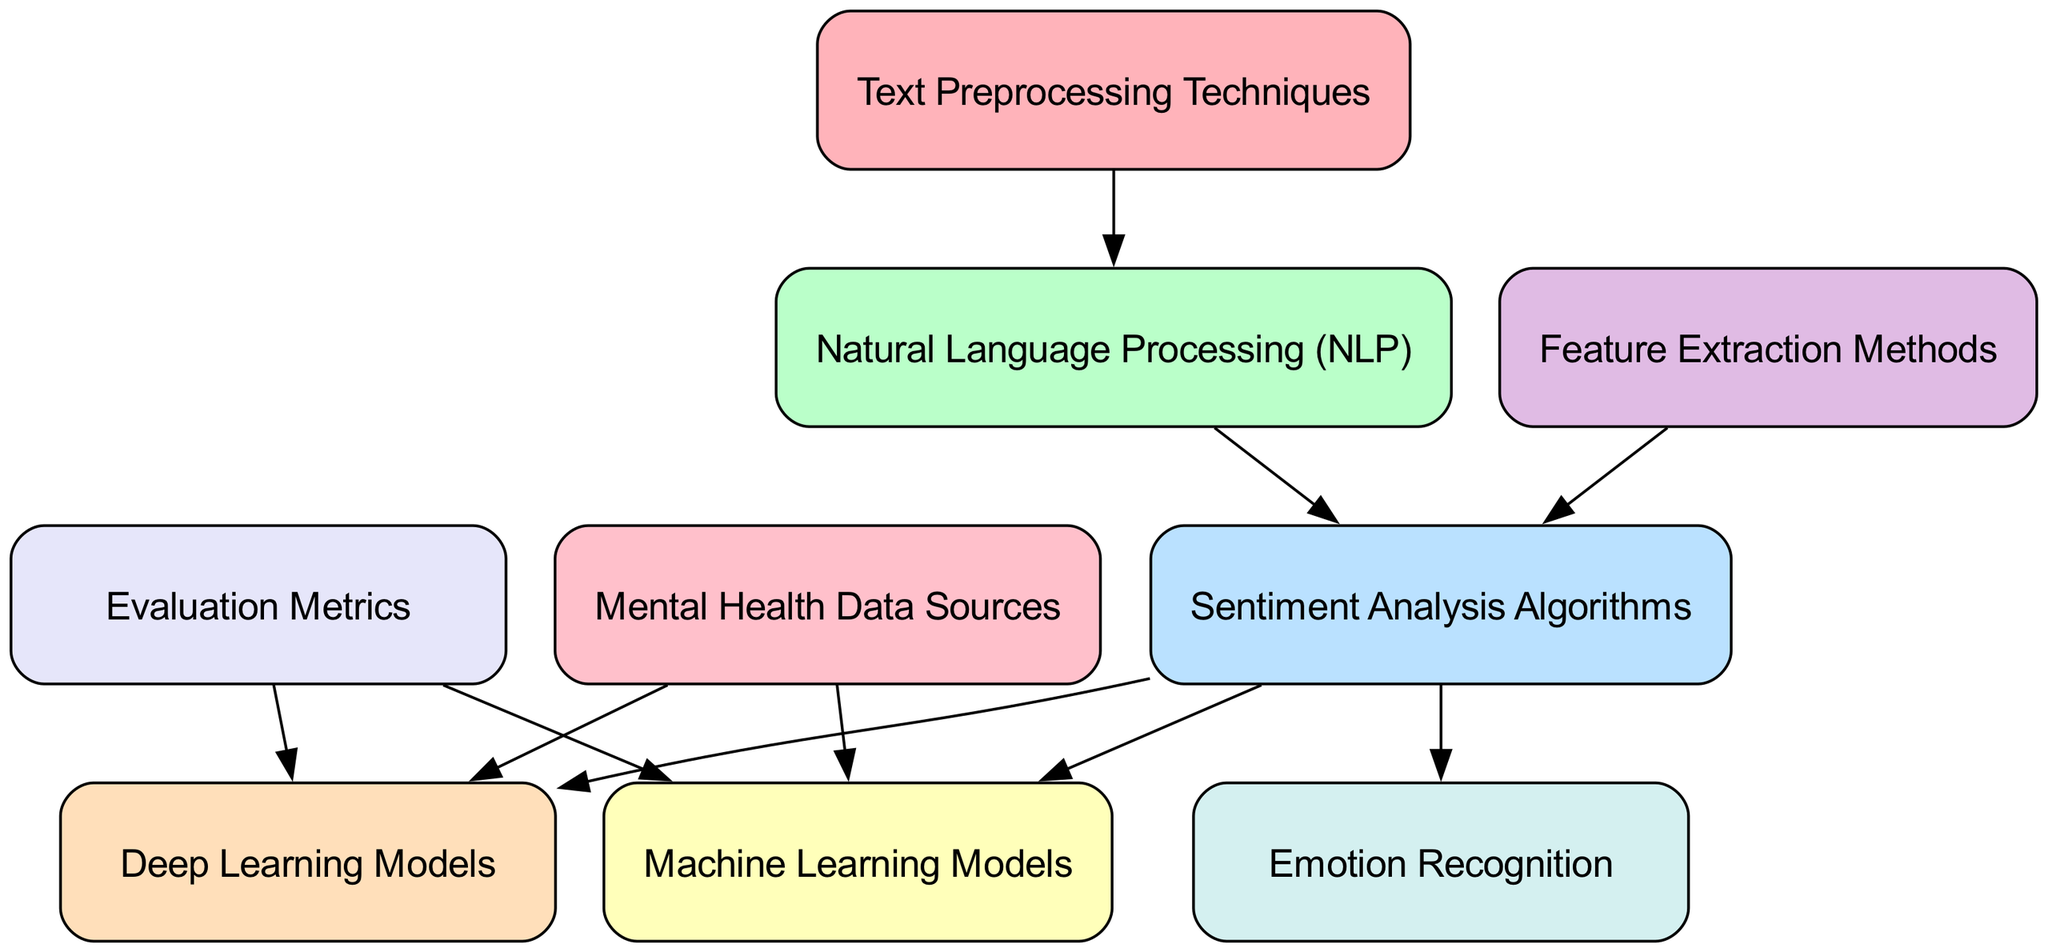What are the nodes in the diagram? The nodes listed in the diagram are: Text Preprocessing Techniques, Natural Language Processing (NLP), Sentiment Analysis Algorithms, Machine Learning Models, Deep Learning Models, Feature Extraction Methods, Emotion Recognition, Mental Health Data Sources, and Evaluation Metrics.
Answer: Text Preprocessing Techniques, Natural Language Processing (NLP), Sentiment Analysis Algorithms, Machine Learning Models, Deep Learning Models, Feature Extraction Methods, Emotion Recognition, Mental Health Data Sources, Evaluation Metrics How many edges are there in the diagram? By counting the lines connecting the nodes (edges), we find that there are a total of 10 edges in the diagram.
Answer: 10 What is the target of the "Natural Language Processing (NLP)" node? The "Natural Language Processing (NLP)" node points to the "Sentiment Analysis Algorithms" node, establishing a direct relationship where NLP leads into sentiment analysis.
Answer: Sentiment Analysis Algorithms Which node is a direct parent of "Emotion Recognition"? Tracing the edges, "Sentiment Analysis Algorithms" is the direct parent node that points to "Emotion Recognition," showing how sentiment analysis feeds into understanding emotions.
Answer: Sentiment Analysis Algorithms What types of models do "Sentiment Analysis Algorithms" connect to? The "Sentiment Analysis Algorithms" node is connected to both the "Machine Learning Models" and "Deep Learning Models" nodes, indicating it informs both types of models for processing sentiment.
Answer: Machine Learning Models, Deep Learning Models Which node has the most child nodes? Examining connections, the "Sentiment Analysis Algorithms" node has three child nodes: "Machine Learning Models," "Deep Learning Models," and "Emotion Recognition," making it the node with the most children.
Answer: Sentiment Analysis Algorithms What is the relationship between "Mental Health Data Sources" and model types? "Mental Health Data Sources" connects to both "Machine Learning Models" and "Deep Learning Models," meaning these data sources inform and are crucial for both types of models in sentiment analysis.
Answer: Machine Learning Models, Deep Learning Models Which node is not connected to "Sentiment Analysis Algorithms"? The node "Feature Extraction Methods" does not have a direct edge leading to "Sentiment Analysis Algorithms" in the diagram, indicating it's not directly tied to the sentiment analysis process.
Answer: Feature Extraction Methods How does "Text Preprocessing Techniques" influence the diagram? "Text Preprocessing Techniques" is the starting point that connects to "Natural Language Processing (NLP)," showing its foundational role in preparing text for further analysis in the diagram.
Answer: Natural Language Processing (NLP) 